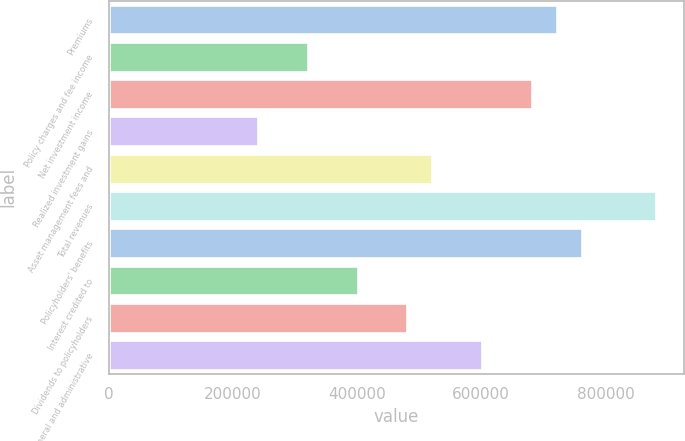<chart> <loc_0><loc_0><loc_500><loc_500><bar_chart><fcel>Premiums<fcel>Policy charges and fee income<fcel>Net investment income<fcel>Realized investment gains<fcel>Asset management fees and<fcel>Total revenues<fcel>Policyholders' benefits<fcel>Interest credited to<fcel>Dividends to policyholders<fcel>General and administrative<nl><fcel>721489<fcel>320663<fcel>681406<fcel>240498<fcel>521076<fcel>881819<fcel>761571<fcel>400828<fcel>480993<fcel>601241<nl></chart> 